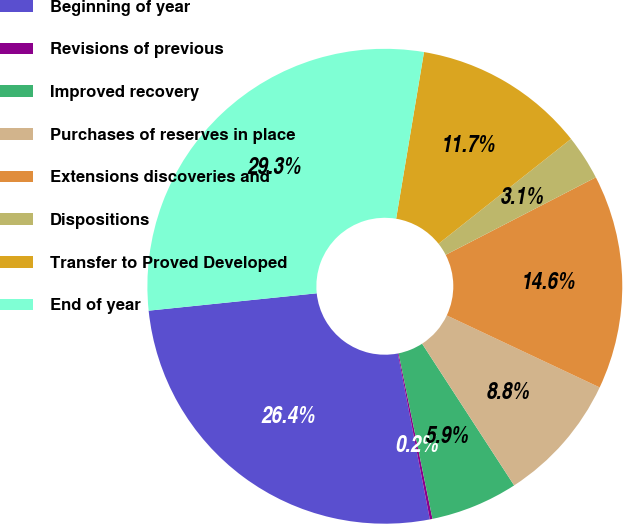Convert chart. <chart><loc_0><loc_0><loc_500><loc_500><pie_chart><fcel>Beginning of year<fcel>Revisions of previous<fcel>Improved recovery<fcel>Purchases of reserves in place<fcel>Extensions discoveries and<fcel>Dispositions<fcel>Transfer to Proved Developed<fcel>End of year<nl><fcel>26.4%<fcel>0.18%<fcel>5.95%<fcel>8.83%<fcel>14.59%<fcel>3.07%<fcel>11.71%<fcel>29.28%<nl></chart> 